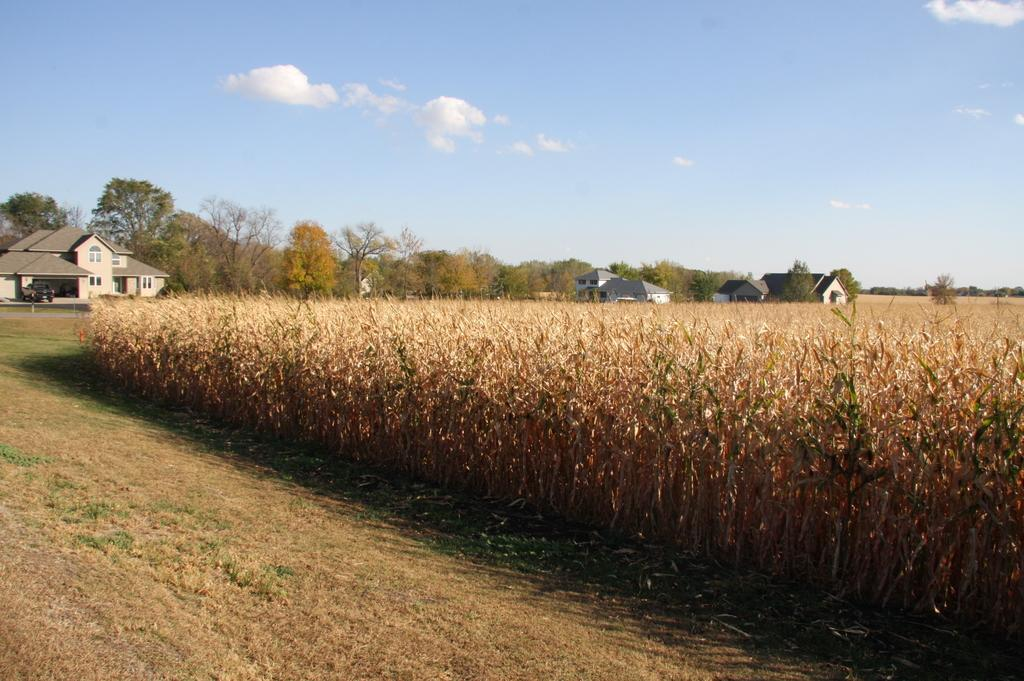What type of vegetation can be seen in the image? There are plants and grass in the image. What type of structures are visible in the image? There are houses in the image. What other natural elements can be seen in the image? There are trees in the image. What is visible in the background of the image? The sky is visible in the background of the image. What type of bun is being used to hold the plants in the image? There is no mention of a bun in the image, as it features plants, grass, houses, trees, and the sky. 